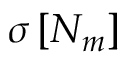<formula> <loc_0><loc_0><loc_500><loc_500>\sigma \left [ N _ { m } \right ]</formula> 